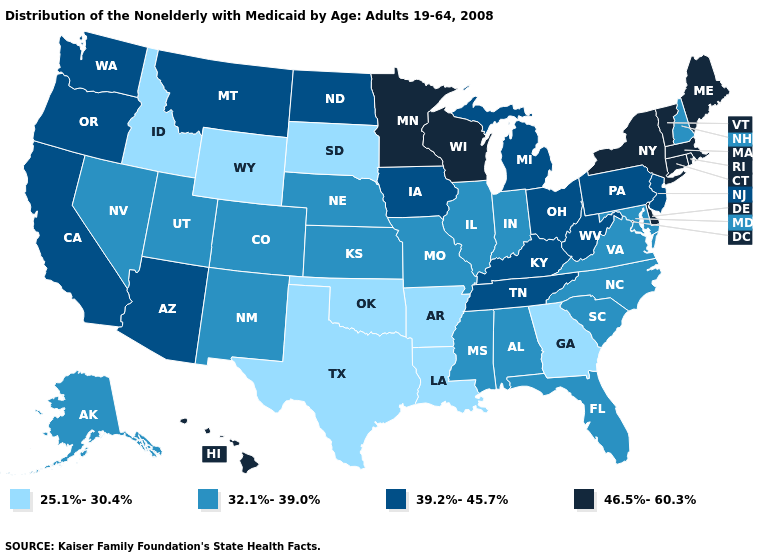Name the states that have a value in the range 46.5%-60.3%?
Give a very brief answer. Connecticut, Delaware, Hawaii, Maine, Massachusetts, Minnesota, New York, Rhode Island, Vermont, Wisconsin. Which states have the highest value in the USA?
Be succinct. Connecticut, Delaware, Hawaii, Maine, Massachusetts, Minnesota, New York, Rhode Island, Vermont, Wisconsin. Among the states that border Wyoming , does Montana have the lowest value?
Be succinct. No. What is the lowest value in the MidWest?
Write a very short answer. 25.1%-30.4%. Name the states that have a value in the range 39.2%-45.7%?
Answer briefly. Arizona, California, Iowa, Kentucky, Michigan, Montana, New Jersey, North Dakota, Ohio, Oregon, Pennsylvania, Tennessee, Washington, West Virginia. Among the states that border New York , does Massachusetts have the highest value?
Short answer required. Yes. Name the states that have a value in the range 32.1%-39.0%?
Short answer required. Alabama, Alaska, Colorado, Florida, Illinois, Indiana, Kansas, Maryland, Mississippi, Missouri, Nebraska, Nevada, New Hampshire, New Mexico, North Carolina, South Carolina, Utah, Virginia. Does Washington have the lowest value in the West?
Concise answer only. No. Does South Dakota have the lowest value in the MidWest?
Keep it brief. Yes. What is the value of Indiana?
Write a very short answer. 32.1%-39.0%. Name the states that have a value in the range 25.1%-30.4%?
Short answer required. Arkansas, Georgia, Idaho, Louisiana, Oklahoma, South Dakota, Texas, Wyoming. What is the highest value in the South ?
Quick response, please. 46.5%-60.3%. What is the value of Ohio?
Short answer required. 39.2%-45.7%. What is the lowest value in the MidWest?
Give a very brief answer. 25.1%-30.4%. 